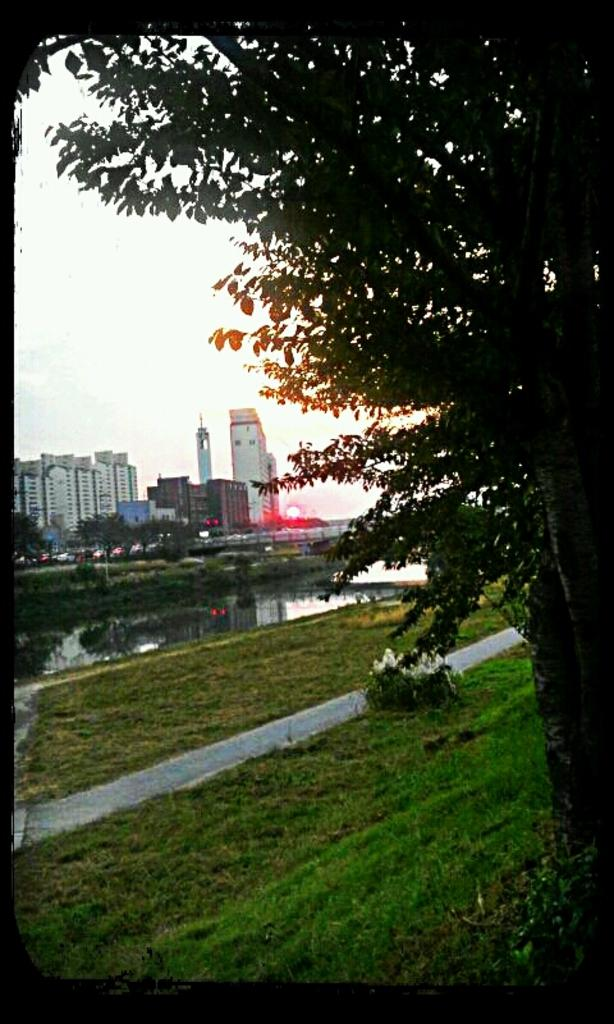What type of structures can be seen in the image? There are buildings in the image. What natural elements are present in the image? There are trees, grass, and water in the image. What man-made objects can be seen in the image? There are vehicles and a bridge in the image. What celestial body is visible in the image? The sun is visible in the image. What part of the natural environment is visible in the image? The sky is visible in the image. Can you tell me how many brothers are depicted in the image? There are no people, let alone brothers, present in the image. What type of tail is attached to the bridge in the image? There is no tail present in the image, as bridges do not have tails. 